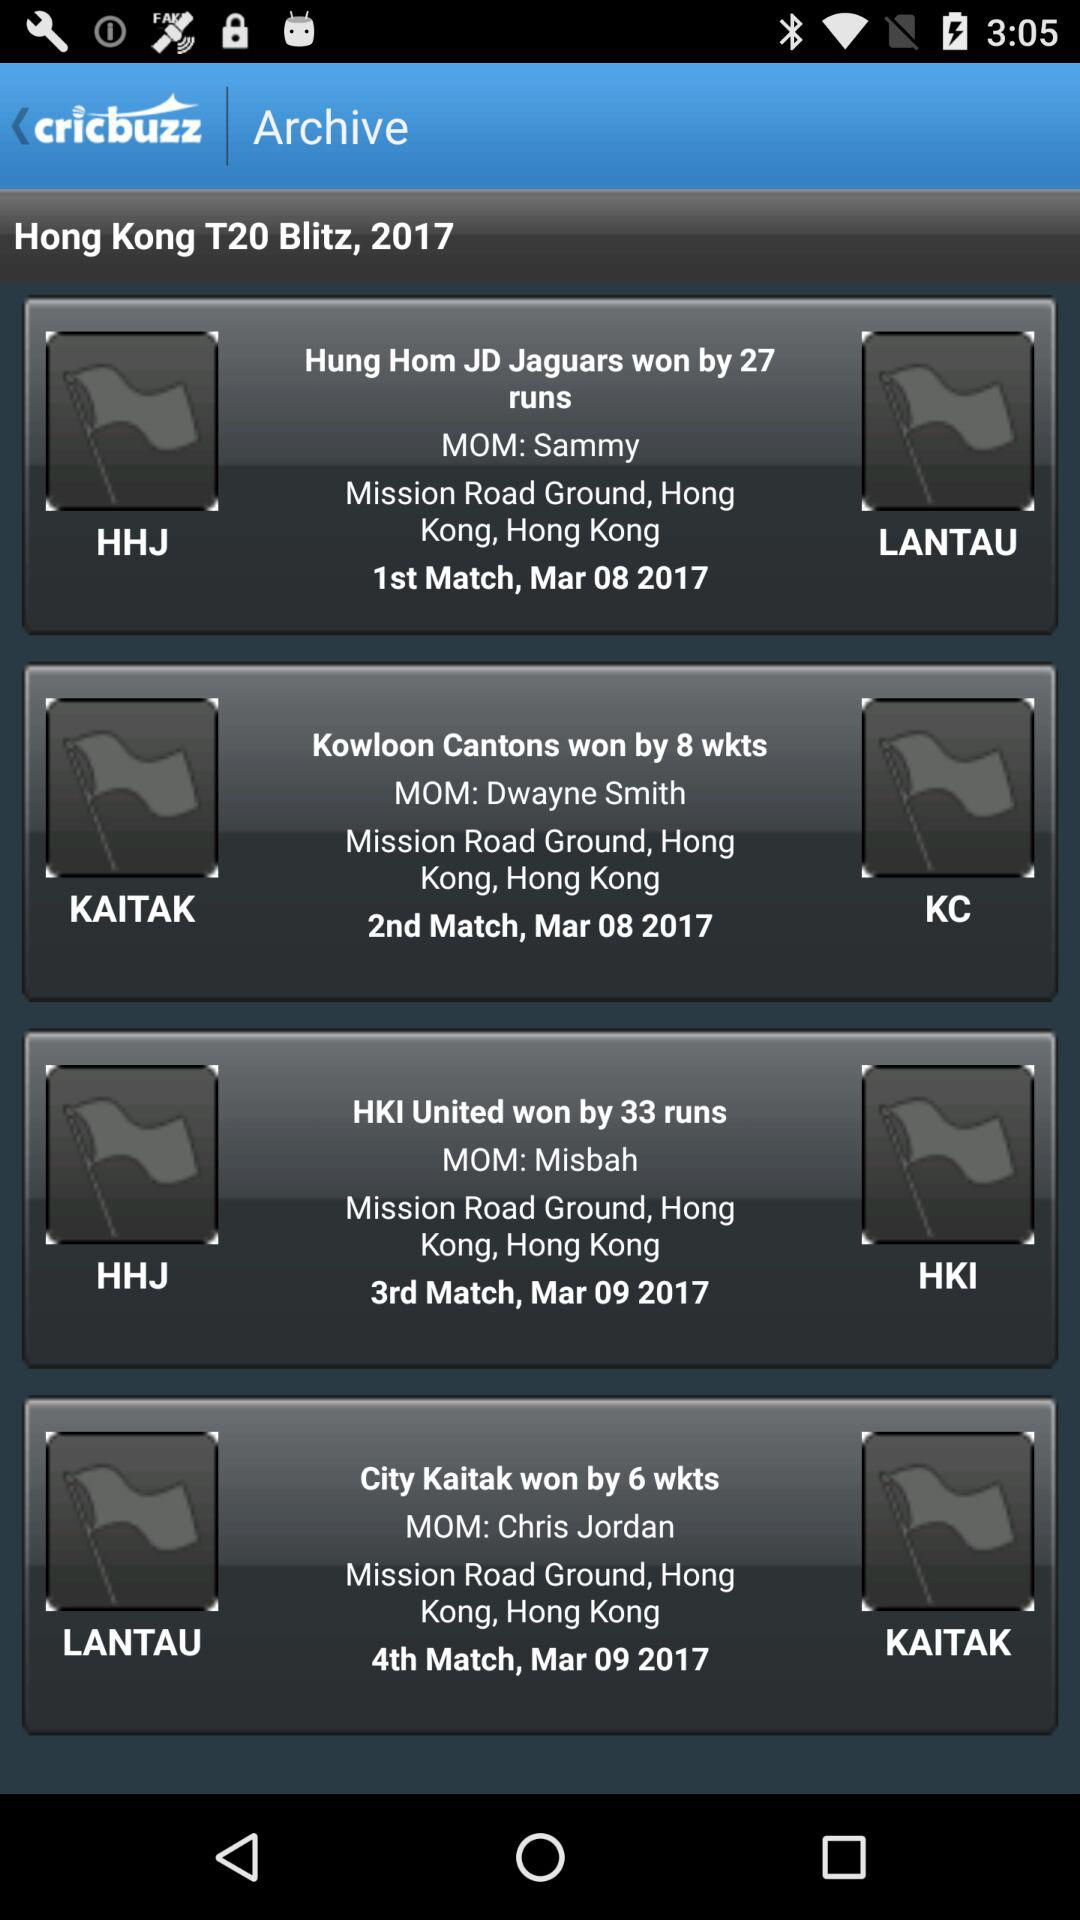On which date was the 2nd match played? The 2nd match was played on March 8, 2017. 